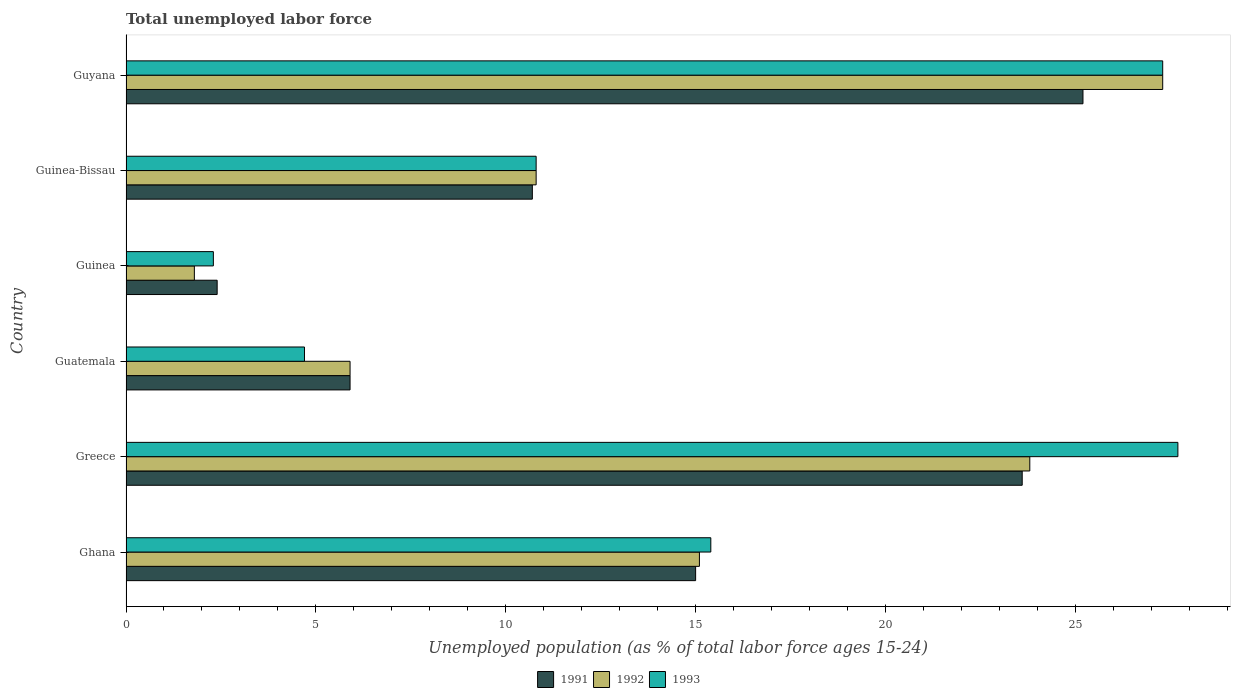How many different coloured bars are there?
Offer a very short reply. 3. Are the number of bars on each tick of the Y-axis equal?
Provide a succinct answer. Yes. How many bars are there on the 1st tick from the top?
Ensure brevity in your answer.  3. What is the label of the 1st group of bars from the top?
Your response must be concise. Guyana. What is the percentage of unemployed population in in 1991 in Guinea?
Offer a terse response. 2.4. Across all countries, what is the maximum percentage of unemployed population in in 1992?
Your answer should be very brief. 27.3. Across all countries, what is the minimum percentage of unemployed population in in 1993?
Keep it short and to the point. 2.3. In which country was the percentage of unemployed population in in 1992 maximum?
Your answer should be compact. Guyana. In which country was the percentage of unemployed population in in 1991 minimum?
Ensure brevity in your answer.  Guinea. What is the total percentage of unemployed population in in 1993 in the graph?
Ensure brevity in your answer.  88.2. What is the difference between the percentage of unemployed population in in 1991 in Ghana and that in Guyana?
Your answer should be compact. -10.2. What is the difference between the percentage of unemployed population in in 1993 in Greece and the percentage of unemployed population in in 1991 in Guinea?
Make the answer very short. 25.3. What is the average percentage of unemployed population in in 1992 per country?
Your response must be concise. 14.12. What is the difference between the percentage of unemployed population in in 1991 and percentage of unemployed population in in 1992 in Guinea-Bissau?
Make the answer very short. -0.1. In how many countries, is the percentage of unemployed population in in 1992 greater than 19 %?
Offer a terse response. 2. What is the ratio of the percentage of unemployed population in in 1991 in Greece to that in Guinea-Bissau?
Provide a short and direct response. 2.21. Is the percentage of unemployed population in in 1992 in Ghana less than that in Greece?
Ensure brevity in your answer.  Yes. What is the difference between the highest and the second highest percentage of unemployed population in in 1991?
Your answer should be compact. 1.6. What is the difference between the highest and the lowest percentage of unemployed population in in 1993?
Your answer should be compact. 25.4. In how many countries, is the percentage of unemployed population in in 1992 greater than the average percentage of unemployed population in in 1992 taken over all countries?
Ensure brevity in your answer.  3. Is the sum of the percentage of unemployed population in in 1991 in Guatemala and Guinea-Bissau greater than the maximum percentage of unemployed population in in 1992 across all countries?
Offer a very short reply. No. What does the 1st bar from the top in Guinea represents?
Ensure brevity in your answer.  1993. What does the 3rd bar from the bottom in Greece represents?
Provide a short and direct response. 1993. How many bars are there?
Provide a short and direct response. 18. Are all the bars in the graph horizontal?
Your answer should be very brief. Yes. What is the difference between two consecutive major ticks on the X-axis?
Offer a terse response. 5. Are the values on the major ticks of X-axis written in scientific E-notation?
Your response must be concise. No. Does the graph contain grids?
Offer a very short reply. No. Where does the legend appear in the graph?
Provide a short and direct response. Bottom center. What is the title of the graph?
Make the answer very short. Total unemployed labor force. Does "1978" appear as one of the legend labels in the graph?
Keep it short and to the point. No. What is the label or title of the X-axis?
Make the answer very short. Unemployed population (as % of total labor force ages 15-24). What is the label or title of the Y-axis?
Offer a terse response. Country. What is the Unemployed population (as % of total labor force ages 15-24) in 1992 in Ghana?
Your answer should be very brief. 15.1. What is the Unemployed population (as % of total labor force ages 15-24) of 1993 in Ghana?
Make the answer very short. 15.4. What is the Unemployed population (as % of total labor force ages 15-24) of 1991 in Greece?
Provide a short and direct response. 23.6. What is the Unemployed population (as % of total labor force ages 15-24) in 1992 in Greece?
Ensure brevity in your answer.  23.8. What is the Unemployed population (as % of total labor force ages 15-24) in 1993 in Greece?
Your response must be concise. 27.7. What is the Unemployed population (as % of total labor force ages 15-24) in 1991 in Guatemala?
Provide a succinct answer. 5.9. What is the Unemployed population (as % of total labor force ages 15-24) of 1992 in Guatemala?
Your response must be concise. 5.9. What is the Unemployed population (as % of total labor force ages 15-24) of 1993 in Guatemala?
Your response must be concise. 4.7. What is the Unemployed population (as % of total labor force ages 15-24) in 1991 in Guinea?
Your response must be concise. 2.4. What is the Unemployed population (as % of total labor force ages 15-24) of 1992 in Guinea?
Your answer should be compact. 1.8. What is the Unemployed population (as % of total labor force ages 15-24) of 1993 in Guinea?
Give a very brief answer. 2.3. What is the Unemployed population (as % of total labor force ages 15-24) in 1991 in Guinea-Bissau?
Keep it short and to the point. 10.7. What is the Unemployed population (as % of total labor force ages 15-24) in 1992 in Guinea-Bissau?
Make the answer very short. 10.8. What is the Unemployed population (as % of total labor force ages 15-24) of 1993 in Guinea-Bissau?
Ensure brevity in your answer.  10.8. What is the Unemployed population (as % of total labor force ages 15-24) in 1991 in Guyana?
Your response must be concise. 25.2. What is the Unemployed population (as % of total labor force ages 15-24) in 1992 in Guyana?
Your answer should be compact. 27.3. What is the Unemployed population (as % of total labor force ages 15-24) of 1993 in Guyana?
Give a very brief answer. 27.3. Across all countries, what is the maximum Unemployed population (as % of total labor force ages 15-24) in 1991?
Your answer should be compact. 25.2. Across all countries, what is the maximum Unemployed population (as % of total labor force ages 15-24) in 1992?
Keep it short and to the point. 27.3. Across all countries, what is the maximum Unemployed population (as % of total labor force ages 15-24) in 1993?
Provide a succinct answer. 27.7. Across all countries, what is the minimum Unemployed population (as % of total labor force ages 15-24) of 1991?
Provide a short and direct response. 2.4. Across all countries, what is the minimum Unemployed population (as % of total labor force ages 15-24) in 1992?
Make the answer very short. 1.8. Across all countries, what is the minimum Unemployed population (as % of total labor force ages 15-24) of 1993?
Offer a very short reply. 2.3. What is the total Unemployed population (as % of total labor force ages 15-24) of 1991 in the graph?
Provide a succinct answer. 82.8. What is the total Unemployed population (as % of total labor force ages 15-24) in 1992 in the graph?
Provide a short and direct response. 84.7. What is the total Unemployed population (as % of total labor force ages 15-24) in 1993 in the graph?
Offer a very short reply. 88.2. What is the difference between the Unemployed population (as % of total labor force ages 15-24) in 1992 in Ghana and that in Greece?
Your answer should be very brief. -8.7. What is the difference between the Unemployed population (as % of total labor force ages 15-24) of 1993 in Ghana and that in Greece?
Offer a terse response. -12.3. What is the difference between the Unemployed population (as % of total labor force ages 15-24) of 1992 in Ghana and that in Guatemala?
Provide a short and direct response. 9.2. What is the difference between the Unemployed population (as % of total labor force ages 15-24) in 1991 in Ghana and that in Guinea-Bissau?
Make the answer very short. 4.3. What is the difference between the Unemployed population (as % of total labor force ages 15-24) of 1991 in Ghana and that in Guyana?
Your answer should be compact. -10.2. What is the difference between the Unemployed population (as % of total labor force ages 15-24) of 1992 in Ghana and that in Guyana?
Give a very brief answer. -12.2. What is the difference between the Unemployed population (as % of total labor force ages 15-24) in 1993 in Ghana and that in Guyana?
Provide a succinct answer. -11.9. What is the difference between the Unemployed population (as % of total labor force ages 15-24) of 1991 in Greece and that in Guinea?
Ensure brevity in your answer.  21.2. What is the difference between the Unemployed population (as % of total labor force ages 15-24) in 1993 in Greece and that in Guinea?
Your answer should be compact. 25.4. What is the difference between the Unemployed population (as % of total labor force ages 15-24) in 1991 in Greece and that in Guinea-Bissau?
Offer a very short reply. 12.9. What is the difference between the Unemployed population (as % of total labor force ages 15-24) of 1992 in Greece and that in Guinea-Bissau?
Ensure brevity in your answer.  13. What is the difference between the Unemployed population (as % of total labor force ages 15-24) in 1992 in Greece and that in Guyana?
Offer a very short reply. -3.5. What is the difference between the Unemployed population (as % of total labor force ages 15-24) of 1993 in Greece and that in Guyana?
Ensure brevity in your answer.  0.4. What is the difference between the Unemployed population (as % of total labor force ages 15-24) in 1991 in Guatemala and that in Guinea?
Your answer should be compact. 3.5. What is the difference between the Unemployed population (as % of total labor force ages 15-24) in 1992 in Guatemala and that in Guinea?
Give a very brief answer. 4.1. What is the difference between the Unemployed population (as % of total labor force ages 15-24) of 1991 in Guatemala and that in Guinea-Bissau?
Make the answer very short. -4.8. What is the difference between the Unemployed population (as % of total labor force ages 15-24) of 1991 in Guatemala and that in Guyana?
Make the answer very short. -19.3. What is the difference between the Unemployed population (as % of total labor force ages 15-24) of 1992 in Guatemala and that in Guyana?
Your response must be concise. -21.4. What is the difference between the Unemployed population (as % of total labor force ages 15-24) in 1993 in Guatemala and that in Guyana?
Keep it short and to the point. -22.6. What is the difference between the Unemployed population (as % of total labor force ages 15-24) of 1991 in Guinea and that in Guinea-Bissau?
Keep it short and to the point. -8.3. What is the difference between the Unemployed population (as % of total labor force ages 15-24) in 1992 in Guinea and that in Guinea-Bissau?
Make the answer very short. -9. What is the difference between the Unemployed population (as % of total labor force ages 15-24) in 1991 in Guinea and that in Guyana?
Provide a short and direct response. -22.8. What is the difference between the Unemployed population (as % of total labor force ages 15-24) in 1992 in Guinea and that in Guyana?
Provide a succinct answer. -25.5. What is the difference between the Unemployed population (as % of total labor force ages 15-24) of 1993 in Guinea and that in Guyana?
Your answer should be very brief. -25. What is the difference between the Unemployed population (as % of total labor force ages 15-24) of 1992 in Guinea-Bissau and that in Guyana?
Your response must be concise. -16.5. What is the difference between the Unemployed population (as % of total labor force ages 15-24) in 1993 in Guinea-Bissau and that in Guyana?
Make the answer very short. -16.5. What is the difference between the Unemployed population (as % of total labor force ages 15-24) in 1991 in Ghana and the Unemployed population (as % of total labor force ages 15-24) in 1993 in Greece?
Give a very brief answer. -12.7. What is the difference between the Unemployed population (as % of total labor force ages 15-24) of 1992 in Ghana and the Unemployed population (as % of total labor force ages 15-24) of 1993 in Guatemala?
Your answer should be compact. 10.4. What is the difference between the Unemployed population (as % of total labor force ages 15-24) of 1992 in Ghana and the Unemployed population (as % of total labor force ages 15-24) of 1993 in Guinea?
Ensure brevity in your answer.  12.8. What is the difference between the Unemployed population (as % of total labor force ages 15-24) of 1992 in Ghana and the Unemployed population (as % of total labor force ages 15-24) of 1993 in Guinea-Bissau?
Make the answer very short. 4.3. What is the difference between the Unemployed population (as % of total labor force ages 15-24) in 1991 in Ghana and the Unemployed population (as % of total labor force ages 15-24) in 1993 in Guyana?
Your answer should be very brief. -12.3. What is the difference between the Unemployed population (as % of total labor force ages 15-24) of 1992 in Ghana and the Unemployed population (as % of total labor force ages 15-24) of 1993 in Guyana?
Offer a terse response. -12.2. What is the difference between the Unemployed population (as % of total labor force ages 15-24) of 1991 in Greece and the Unemployed population (as % of total labor force ages 15-24) of 1992 in Guatemala?
Your response must be concise. 17.7. What is the difference between the Unemployed population (as % of total labor force ages 15-24) in 1991 in Greece and the Unemployed population (as % of total labor force ages 15-24) in 1993 in Guatemala?
Keep it short and to the point. 18.9. What is the difference between the Unemployed population (as % of total labor force ages 15-24) of 1991 in Greece and the Unemployed population (as % of total labor force ages 15-24) of 1992 in Guinea?
Provide a succinct answer. 21.8. What is the difference between the Unemployed population (as % of total labor force ages 15-24) of 1991 in Greece and the Unemployed population (as % of total labor force ages 15-24) of 1993 in Guinea?
Ensure brevity in your answer.  21.3. What is the difference between the Unemployed population (as % of total labor force ages 15-24) in 1991 in Greece and the Unemployed population (as % of total labor force ages 15-24) in 1992 in Guyana?
Make the answer very short. -3.7. What is the difference between the Unemployed population (as % of total labor force ages 15-24) of 1991 in Greece and the Unemployed population (as % of total labor force ages 15-24) of 1993 in Guyana?
Provide a succinct answer. -3.7. What is the difference between the Unemployed population (as % of total labor force ages 15-24) of 1992 in Greece and the Unemployed population (as % of total labor force ages 15-24) of 1993 in Guyana?
Offer a terse response. -3.5. What is the difference between the Unemployed population (as % of total labor force ages 15-24) of 1991 in Guatemala and the Unemployed population (as % of total labor force ages 15-24) of 1992 in Guinea?
Keep it short and to the point. 4.1. What is the difference between the Unemployed population (as % of total labor force ages 15-24) in 1991 in Guatemala and the Unemployed population (as % of total labor force ages 15-24) in 1993 in Guinea?
Your answer should be very brief. 3.6. What is the difference between the Unemployed population (as % of total labor force ages 15-24) in 1991 in Guatemala and the Unemployed population (as % of total labor force ages 15-24) in 1993 in Guinea-Bissau?
Your answer should be compact. -4.9. What is the difference between the Unemployed population (as % of total labor force ages 15-24) in 1992 in Guatemala and the Unemployed population (as % of total labor force ages 15-24) in 1993 in Guinea-Bissau?
Your answer should be very brief. -4.9. What is the difference between the Unemployed population (as % of total labor force ages 15-24) of 1991 in Guatemala and the Unemployed population (as % of total labor force ages 15-24) of 1992 in Guyana?
Your answer should be very brief. -21.4. What is the difference between the Unemployed population (as % of total labor force ages 15-24) in 1991 in Guatemala and the Unemployed population (as % of total labor force ages 15-24) in 1993 in Guyana?
Provide a short and direct response. -21.4. What is the difference between the Unemployed population (as % of total labor force ages 15-24) of 1992 in Guatemala and the Unemployed population (as % of total labor force ages 15-24) of 1993 in Guyana?
Keep it short and to the point. -21.4. What is the difference between the Unemployed population (as % of total labor force ages 15-24) in 1991 in Guinea and the Unemployed population (as % of total labor force ages 15-24) in 1992 in Guinea-Bissau?
Make the answer very short. -8.4. What is the difference between the Unemployed population (as % of total labor force ages 15-24) in 1991 in Guinea and the Unemployed population (as % of total labor force ages 15-24) in 1993 in Guinea-Bissau?
Offer a very short reply. -8.4. What is the difference between the Unemployed population (as % of total labor force ages 15-24) of 1991 in Guinea and the Unemployed population (as % of total labor force ages 15-24) of 1992 in Guyana?
Offer a terse response. -24.9. What is the difference between the Unemployed population (as % of total labor force ages 15-24) of 1991 in Guinea and the Unemployed population (as % of total labor force ages 15-24) of 1993 in Guyana?
Give a very brief answer. -24.9. What is the difference between the Unemployed population (as % of total labor force ages 15-24) of 1992 in Guinea and the Unemployed population (as % of total labor force ages 15-24) of 1993 in Guyana?
Your response must be concise. -25.5. What is the difference between the Unemployed population (as % of total labor force ages 15-24) in 1991 in Guinea-Bissau and the Unemployed population (as % of total labor force ages 15-24) in 1992 in Guyana?
Ensure brevity in your answer.  -16.6. What is the difference between the Unemployed population (as % of total labor force ages 15-24) of 1991 in Guinea-Bissau and the Unemployed population (as % of total labor force ages 15-24) of 1993 in Guyana?
Your answer should be very brief. -16.6. What is the difference between the Unemployed population (as % of total labor force ages 15-24) of 1992 in Guinea-Bissau and the Unemployed population (as % of total labor force ages 15-24) of 1993 in Guyana?
Offer a very short reply. -16.5. What is the average Unemployed population (as % of total labor force ages 15-24) in 1992 per country?
Make the answer very short. 14.12. What is the average Unemployed population (as % of total labor force ages 15-24) of 1993 per country?
Ensure brevity in your answer.  14.7. What is the difference between the Unemployed population (as % of total labor force ages 15-24) of 1991 and Unemployed population (as % of total labor force ages 15-24) of 1993 in Ghana?
Give a very brief answer. -0.4. What is the difference between the Unemployed population (as % of total labor force ages 15-24) in 1992 and Unemployed population (as % of total labor force ages 15-24) in 1993 in Ghana?
Your response must be concise. -0.3. What is the difference between the Unemployed population (as % of total labor force ages 15-24) in 1991 and Unemployed population (as % of total labor force ages 15-24) in 1992 in Guatemala?
Make the answer very short. 0. What is the difference between the Unemployed population (as % of total labor force ages 15-24) of 1991 and Unemployed population (as % of total labor force ages 15-24) of 1992 in Guinea?
Your answer should be very brief. 0.6. What is the difference between the Unemployed population (as % of total labor force ages 15-24) in 1992 and Unemployed population (as % of total labor force ages 15-24) in 1993 in Guinea?
Give a very brief answer. -0.5. What is the difference between the Unemployed population (as % of total labor force ages 15-24) of 1991 and Unemployed population (as % of total labor force ages 15-24) of 1993 in Guinea-Bissau?
Provide a succinct answer. -0.1. What is the difference between the Unemployed population (as % of total labor force ages 15-24) of 1991 and Unemployed population (as % of total labor force ages 15-24) of 1992 in Guyana?
Your response must be concise. -2.1. What is the difference between the Unemployed population (as % of total labor force ages 15-24) in 1991 and Unemployed population (as % of total labor force ages 15-24) in 1993 in Guyana?
Make the answer very short. -2.1. What is the ratio of the Unemployed population (as % of total labor force ages 15-24) of 1991 in Ghana to that in Greece?
Offer a very short reply. 0.64. What is the ratio of the Unemployed population (as % of total labor force ages 15-24) of 1992 in Ghana to that in Greece?
Your answer should be very brief. 0.63. What is the ratio of the Unemployed population (as % of total labor force ages 15-24) in 1993 in Ghana to that in Greece?
Offer a terse response. 0.56. What is the ratio of the Unemployed population (as % of total labor force ages 15-24) of 1991 in Ghana to that in Guatemala?
Offer a very short reply. 2.54. What is the ratio of the Unemployed population (as % of total labor force ages 15-24) in 1992 in Ghana to that in Guatemala?
Give a very brief answer. 2.56. What is the ratio of the Unemployed population (as % of total labor force ages 15-24) of 1993 in Ghana to that in Guatemala?
Your answer should be very brief. 3.28. What is the ratio of the Unemployed population (as % of total labor force ages 15-24) in 1991 in Ghana to that in Guinea?
Your answer should be compact. 6.25. What is the ratio of the Unemployed population (as % of total labor force ages 15-24) in 1992 in Ghana to that in Guinea?
Offer a terse response. 8.39. What is the ratio of the Unemployed population (as % of total labor force ages 15-24) in 1993 in Ghana to that in Guinea?
Offer a terse response. 6.7. What is the ratio of the Unemployed population (as % of total labor force ages 15-24) of 1991 in Ghana to that in Guinea-Bissau?
Ensure brevity in your answer.  1.4. What is the ratio of the Unemployed population (as % of total labor force ages 15-24) in 1992 in Ghana to that in Guinea-Bissau?
Your response must be concise. 1.4. What is the ratio of the Unemployed population (as % of total labor force ages 15-24) of 1993 in Ghana to that in Guinea-Bissau?
Give a very brief answer. 1.43. What is the ratio of the Unemployed population (as % of total labor force ages 15-24) in 1991 in Ghana to that in Guyana?
Offer a terse response. 0.6. What is the ratio of the Unemployed population (as % of total labor force ages 15-24) in 1992 in Ghana to that in Guyana?
Your answer should be compact. 0.55. What is the ratio of the Unemployed population (as % of total labor force ages 15-24) in 1993 in Ghana to that in Guyana?
Your answer should be very brief. 0.56. What is the ratio of the Unemployed population (as % of total labor force ages 15-24) in 1991 in Greece to that in Guatemala?
Provide a succinct answer. 4. What is the ratio of the Unemployed population (as % of total labor force ages 15-24) in 1992 in Greece to that in Guatemala?
Your answer should be very brief. 4.03. What is the ratio of the Unemployed population (as % of total labor force ages 15-24) in 1993 in Greece to that in Guatemala?
Offer a very short reply. 5.89. What is the ratio of the Unemployed population (as % of total labor force ages 15-24) in 1991 in Greece to that in Guinea?
Your response must be concise. 9.83. What is the ratio of the Unemployed population (as % of total labor force ages 15-24) in 1992 in Greece to that in Guinea?
Keep it short and to the point. 13.22. What is the ratio of the Unemployed population (as % of total labor force ages 15-24) of 1993 in Greece to that in Guinea?
Your answer should be very brief. 12.04. What is the ratio of the Unemployed population (as % of total labor force ages 15-24) of 1991 in Greece to that in Guinea-Bissau?
Provide a succinct answer. 2.21. What is the ratio of the Unemployed population (as % of total labor force ages 15-24) of 1992 in Greece to that in Guinea-Bissau?
Ensure brevity in your answer.  2.2. What is the ratio of the Unemployed population (as % of total labor force ages 15-24) of 1993 in Greece to that in Guinea-Bissau?
Your answer should be very brief. 2.56. What is the ratio of the Unemployed population (as % of total labor force ages 15-24) of 1991 in Greece to that in Guyana?
Offer a terse response. 0.94. What is the ratio of the Unemployed population (as % of total labor force ages 15-24) of 1992 in Greece to that in Guyana?
Provide a short and direct response. 0.87. What is the ratio of the Unemployed population (as % of total labor force ages 15-24) in 1993 in Greece to that in Guyana?
Your answer should be very brief. 1.01. What is the ratio of the Unemployed population (as % of total labor force ages 15-24) of 1991 in Guatemala to that in Guinea?
Your answer should be very brief. 2.46. What is the ratio of the Unemployed population (as % of total labor force ages 15-24) in 1992 in Guatemala to that in Guinea?
Give a very brief answer. 3.28. What is the ratio of the Unemployed population (as % of total labor force ages 15-24) of 1993 in Guatemala to that in Guinea?
Offer a terse response. 2.04. What is the ratio of the Unemployed population (as % of total labor force ages 15-24) in 1991 in Guatemala to that in Guinea-Bissau?
Your answer should be compact. 0.55. What is the ratio of the Unemployed population (as % of total labor force ages 15-24) in 1992 in Guatemala to that in Guinea-Bissau?
Offer a terse response. 0.55. What is the ratio of the Unemployed population (as % of total labor force ages 15-24) in 1993 in Guatemala to that in Guinea-Bissau?
Keep it short and to the point. 0.44. What is the ratio of the Unemployed population (as % of total labor force ages 15-24) of 1991 in Guatemala to that in Guyana?
Offer a terse response. 0.23. What is the ratio of the Unemployed population (as % of total labor force ages 15-24) of 1992 in Guatemala to that in Guyana?
Your answer should be very brief. 0.22. What is the ratio of the Unemployed population (as % of total labor force ages 15-24) in 1993 in Guatemala to that in Guyana?
Make the answer very short. 0.17. What is the ratio of the Unemployed population (as % of total labor force ages 15-24) of 1991 in Guinea to that in Guinea-Bissau?
Offer a very short reply. 0.22. What is the ratio of the Unemployed population (as % of total labor force ages 15-24) of 1992 in Guinea to that in Guinea-Bissau?
Keep it short and to the point. 0.17. What is the ratio of the Unemployed population (as % of total labor force ages 15-24) of 1993 in Guinea to that in Guinea-Bissau?
Your answer should be very brief. 0.21. What is the ratio of the Unemployed population (as % of total labor force ages 15-24) of 1991 in Guinea to that in Guyana?
Provide a short and direct response. 0.1. What is the ratio of the Unemployed population (as % of total labor force ages 15-24) of 1992 in Guinea to that in Guyana?
Your answer should be very brief. 0.07. What is the ratio of the Unemployed population (as % of total labor force ages 15-24) of 1993 in Guinea to that in Guyana?
Make the answer very short. 0.08. What is the ratio of the Unemployed population (as % of total labor force ages 15-24) in 1991 in Guinea-Bissau to that in Guyana?
Provide a succinct answer. 0.42. What is the ratio of the Unemployed population (as % of total labor force ages 15-24) in 1992 in Guinea-Bissau to that in Guyana?
Make the answer very short. 0.4. What is the ratio of the Unemployed population (as % of total labor force ages 15-24) in 1993 in Guinea-Bissau to that in Guyana?
Provide a short and direct response. 0.4. What is the difference between the highest and the lowest Unemployed population (as % of total labor force ages 15-24) in 1991?
Provide a short and direct response. 22.8. What is the difference between the highest and the lowest Unemployed population (as % of total labor force ages 15-24) of 1993?
Ensure brevity in your answer.  25.4. 